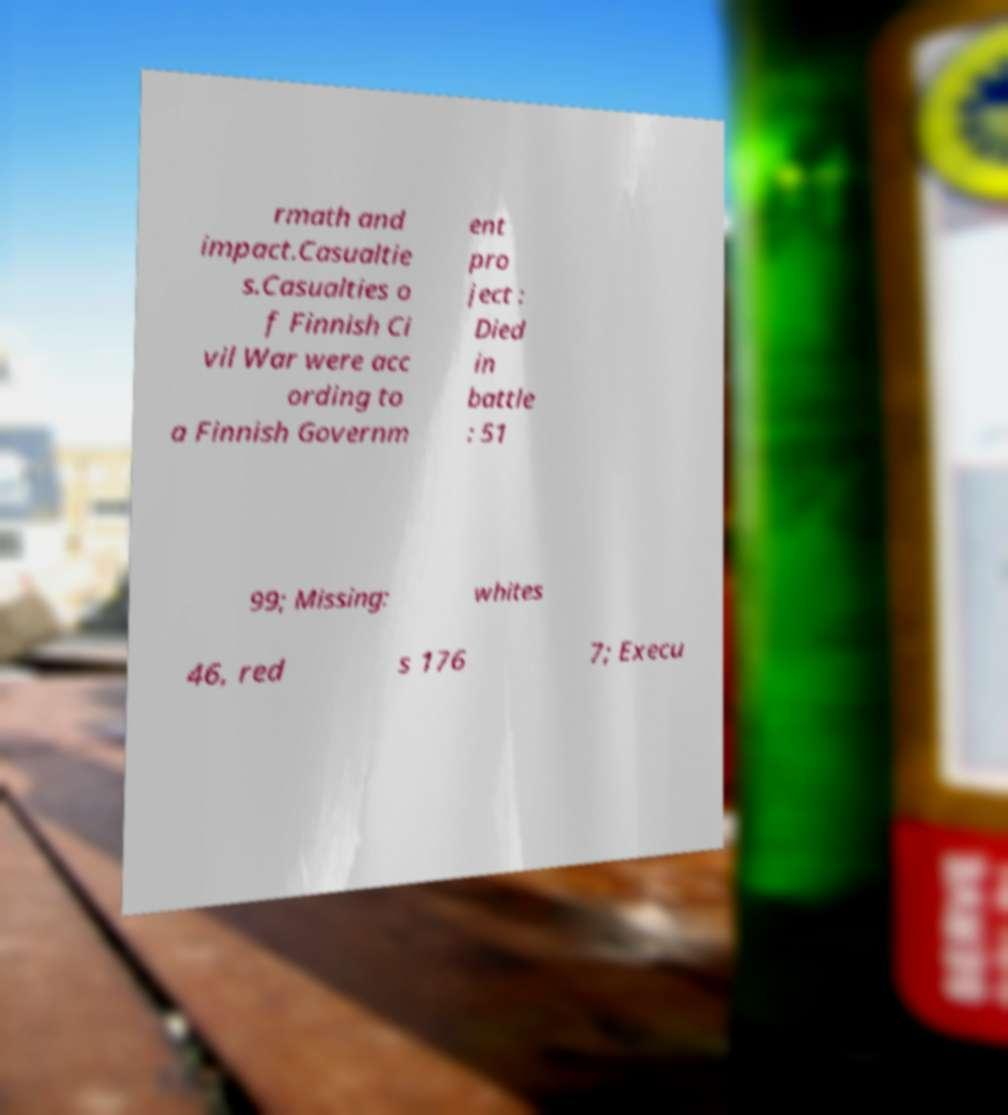Can you read and provide the text displayed in the image?This photo seems to have some interesting text. Can you extract and type it out for me? rmath and impact.Casualtie s.Casualties o f Finnish Ci vil War were acc ording to a Finnish Governm ent pro ject : Died in battle : 51 99; Missing: whites 46, red s 176 7; Execu 